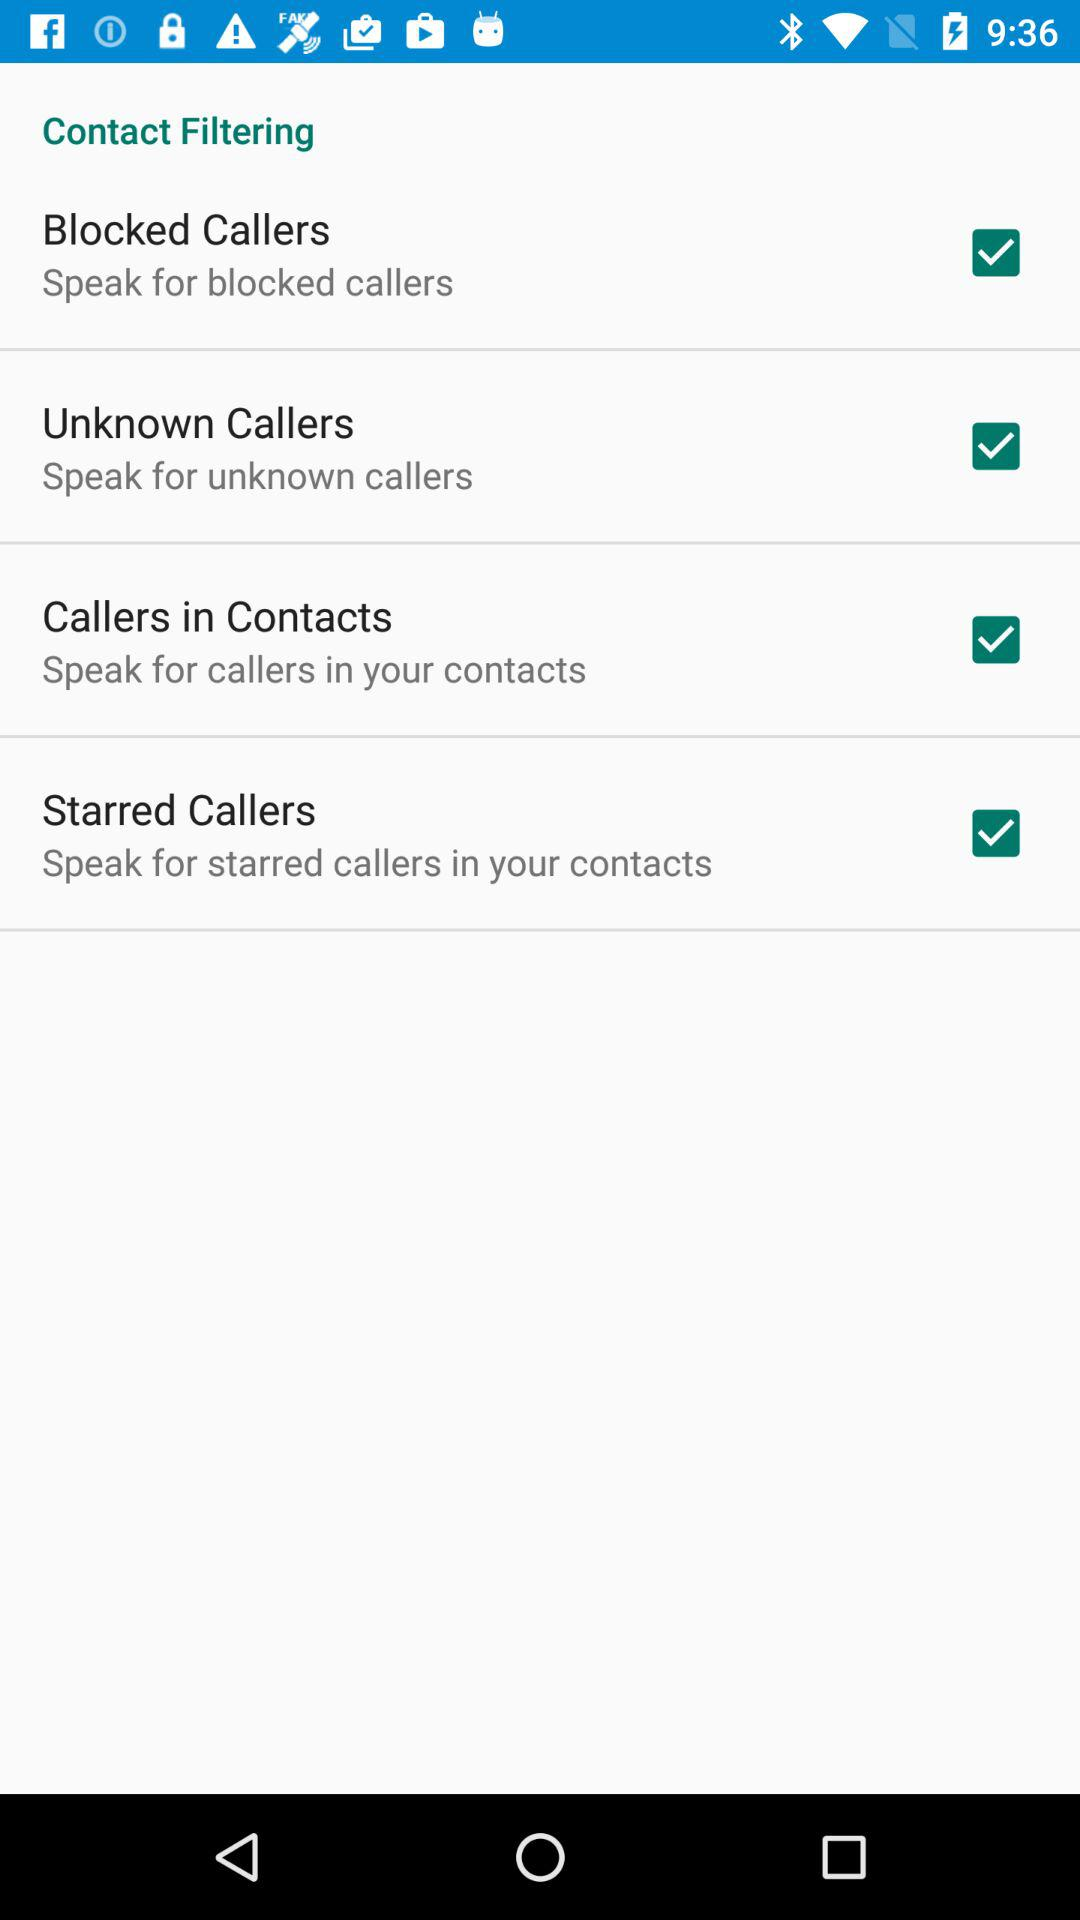How many contact filtering options are available?
Answer the question using a single word or phrase. 4 